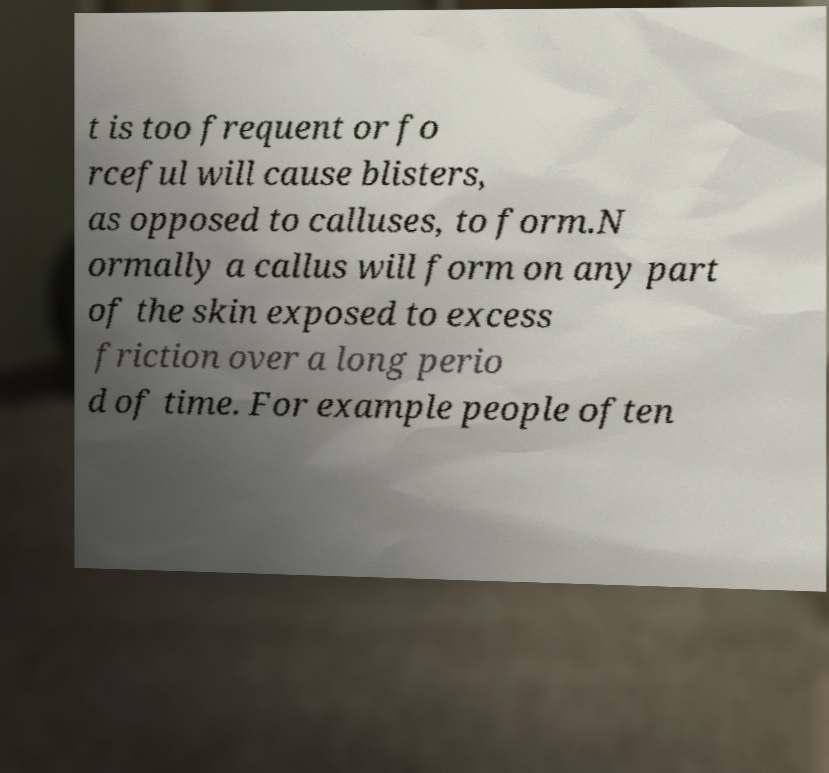I need the written content from this picture converted into text. Can you do that? t is too frequent or fo rceful will cause blisters, as opposed to calluses, to form.N ormally a callus will form on any part of the skin exposed to excess friction over a long perio d of time. For example people often 